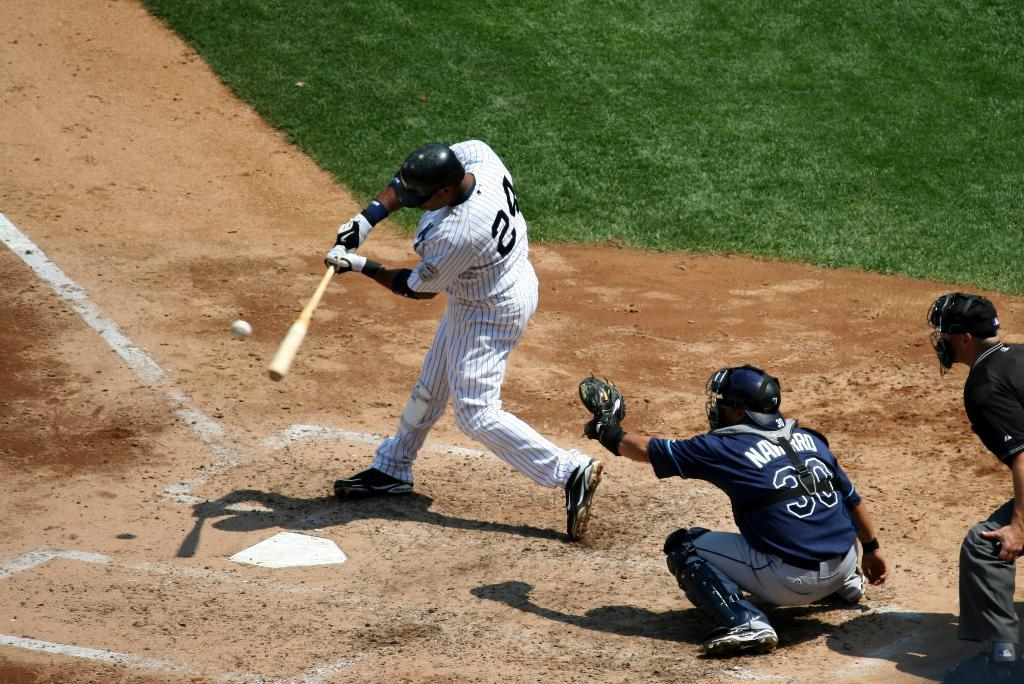What are the three persons in the image doing? They are playing baseball in the image. Can you describe the clothing of one of the persons? One person is wearing a white shirt. What is the person in the white shirt holding? The person in the white shirt is holding a baseball stick. What is another object related to baseball that can be seen in the image? There is a baseball in the image. What type of surface is visible in the image? There is grass visible in the image. What flavor of straw can be seen in the image? There is no straw present in the image, so it is not possible to determine its flavor. 